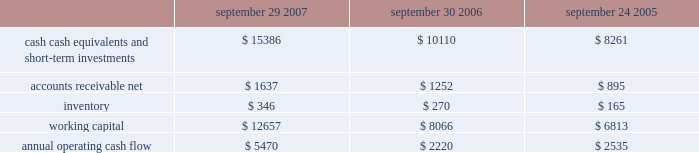No .
159 requires that unrealized gains and losses on items for which the fair value option has been elected be reported in earnings at each reporting date .
Sfas no .
159 is effective for fiscal years beginning after november 15 , 2007 and is required to be adopted by the company beginning in the first quarter of fiscal 2009 .
Although the company will continue to evaluate the application of sfas no .
159 , management does not currently believe adoption will have a material impact on the company 2019s financial condition or operating results .
In september 2006 , the fasb issued sfas no .
157 , fair value measurements , which defines fair value , provides a framework for measuring fair value , and expands the disclosures required for fair value measurements .
Sfas no .
157 applies to other accounting pronouncements that require fair value measurements ; it does not require any new fair value measurements .
Sfas no .
157 is effective for fiscal years beginning after november 15 , 2007 and is required to be adopted by the company beginning in the first quarter of fiscal 2009 .
Although the company will continue to evaluate the application of sfas no .
157 , management does not currently believe adoption will have a material impact on the company 2019s financial condition or operating results .
In june 2006 , the fasb issued fasb interpretation no .
( 2018 2018fin 2019 2019 ) 48 , accounting for uncertainty in income taxes-an interpretation of fasb statement no .
109 .
Fin 48 clarifies the accounting for uncertainty in income taxes by creating a framework for how companies should recognize , measure , present , and disclose in their financial statements uncertain tax positions that they have taken or expect to take in a tax return .
Fin 48 is effective for fiscal years beginning after december 15 , 2006 and is required to be adopted by the company beginning in the first quarter of fiscal 2008 .
Although the company will continue to evaluate the application of fin 48 , management does not currently believe adoption will have a material impact on the company 2019s financial condition or operating results .
Liquidity and capital resources the table presents selected financial information and statistics for each of the last three fiscal years ( dollars in millions ) : september 29 , september 30 , september 24 , 2007 2006 2005 .
As of september 29 , 2007 , the company had $ 15.4 billion in cash , cash equivalents , and short-term investments , an increase of $ 5.3 billion over the same balance at the end of september 30 , 2006 .
The principal components of this net increase were cash generated by operating activities of $ 5.5 billion , proceeds from the issuance of common stock under stock plans of $ 365 million and excess tax benefits from stock-based compensation of $ 377 million .
These increases were partially offset by payments for acquisitions of property , plant , and equipment of $ 735 million and payments for acquisitions of intangible assets of $ 251 million .
The company 2019s short-term investment portfolio is primarily invested in highly rated , liquid investments .
As of september 29 , 2007 and september 30 , 2006 , $ 6.5 billion and $ 4.1 billion , respectively , of the company 2019s cash , cash equivalents , and short-term investments were held by foreign subsidiaries and are generally based in u.s .
Dollar-denominated holdings .
The company believes its existing balances of cash , cash equivalents , and short-term investments will be sufficient to satisfy its working capital needs , capital expenditures , outstanding commitments , and other liquidity requirements associated with its existing operations over the next 12 months. .
What was the change between september 29 , 2007 and september 30 , 2006 , of the company 2019s cash , cash equivalents , and short-term investments were held by foreign subsidiaries and based in u.s . dollar-denominated holdings , in billions? 
Computations: (6.5 - 4.1)
Answer: 2.4. 